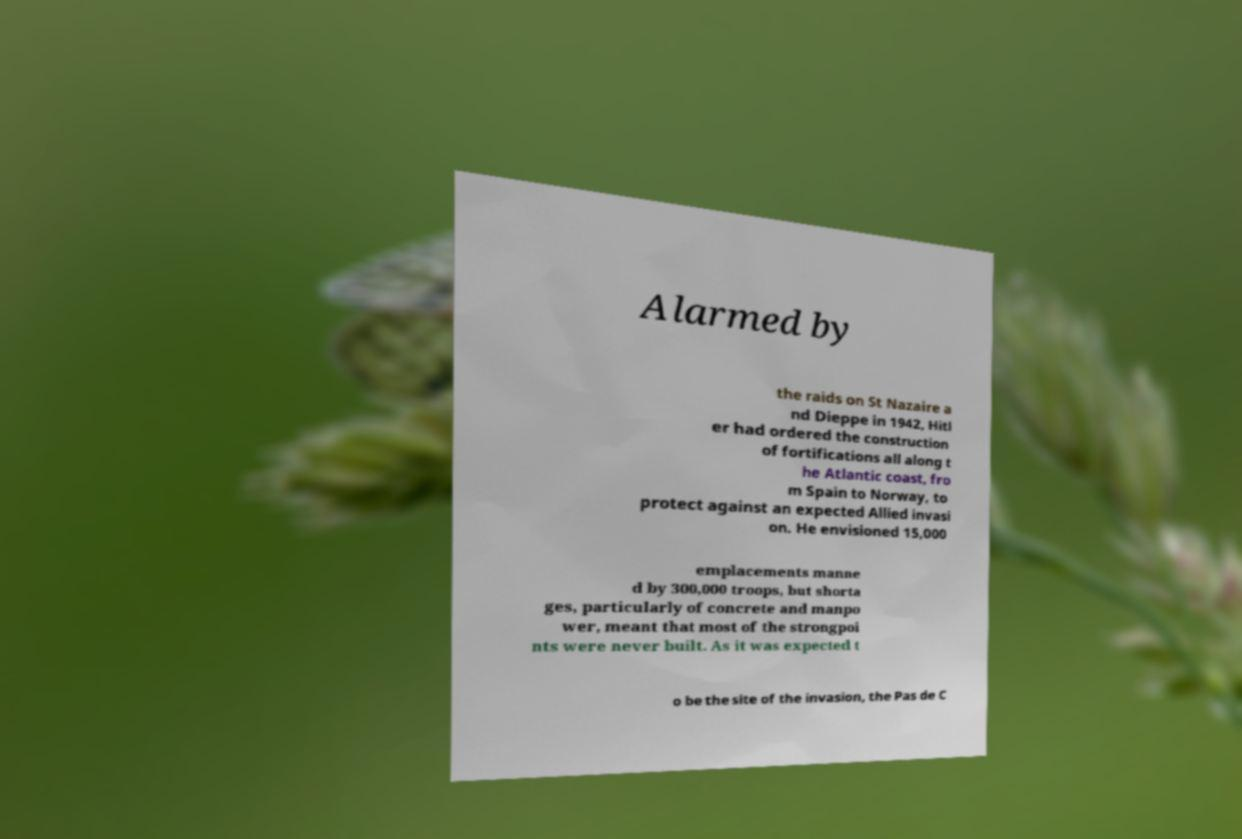Please identify and transcribe the text found in this image. Alarmed by the raids on St Nazaire a nd Dieppe in 1942, Hitl er had ordered the construction of fortifications all along t he Atlantic coast, fro m Spain to Norway, to protect against an expected Allied invasi on. He envisioned 15,000 emplacements manne d by 300,000 troops, but shorta ges, particularly of concrete and manpo wer, meant that most of the strongpoi nts were never built. As it was expected t o be the site of the invasion, the Pas de C 